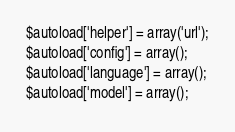Convert code to text. <code><loc_0><loc_0><loc_500><loc_500><_PHP_>$autoload['helper'] = array('url');
$autoload['config'] = array();
$autoload['language'] = array();
$autoload['model'] = array();
</code> 